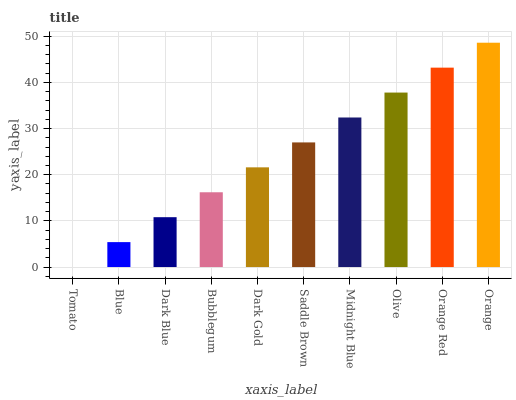Is Tomato the minimum?
Answer yes or no. Yes. Is Orange the maximum?
Answer yes or no. Yes. Is Blue the minimum?
Answer yes or no. No. Is Blue the maximum?
Answer yes or no. No. Is Blue greater than Tomato?
Answer yes or no. Yes. Is Tomato less than Blue?
Answer yes or no. Yes. Is Tomato greater than Blue?
Answer yes or no. No. Is Blue less than Tomato?
Answer yes or no. No. Is Saddle Brown the high median?
Answer yes or no. Yes. Is Dark Gold the low median?
Answer yes or no. Yes. Is Tomato the high median?
Answer yes or no. No. Is Orange the low median?
Answer yes or no. No. 